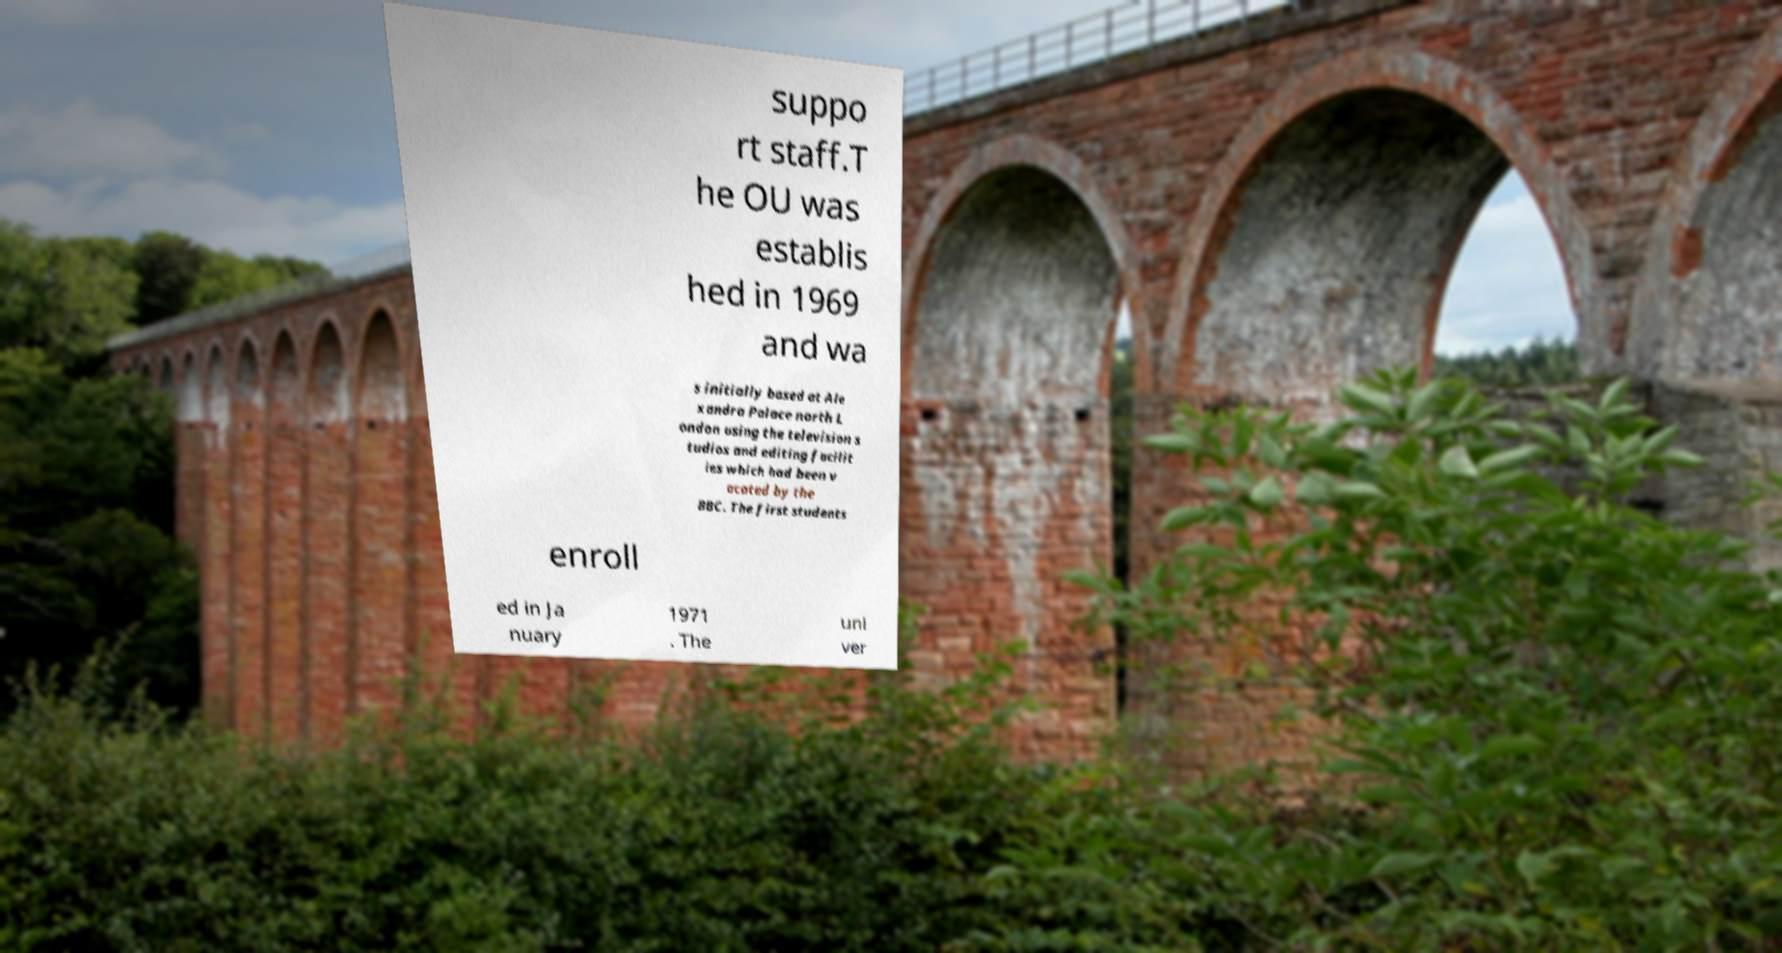Please read and relay the text visible in this image. What does it say? suppo rt staff.T he OU was establis hed in 1969 and wa s initially based at Ale xandra Palace north L ondon using the television s tudios and editing facilit ies which had been v acated by the BBC. The first students enroll ed in Ja nuary 1971 . The uni ver 